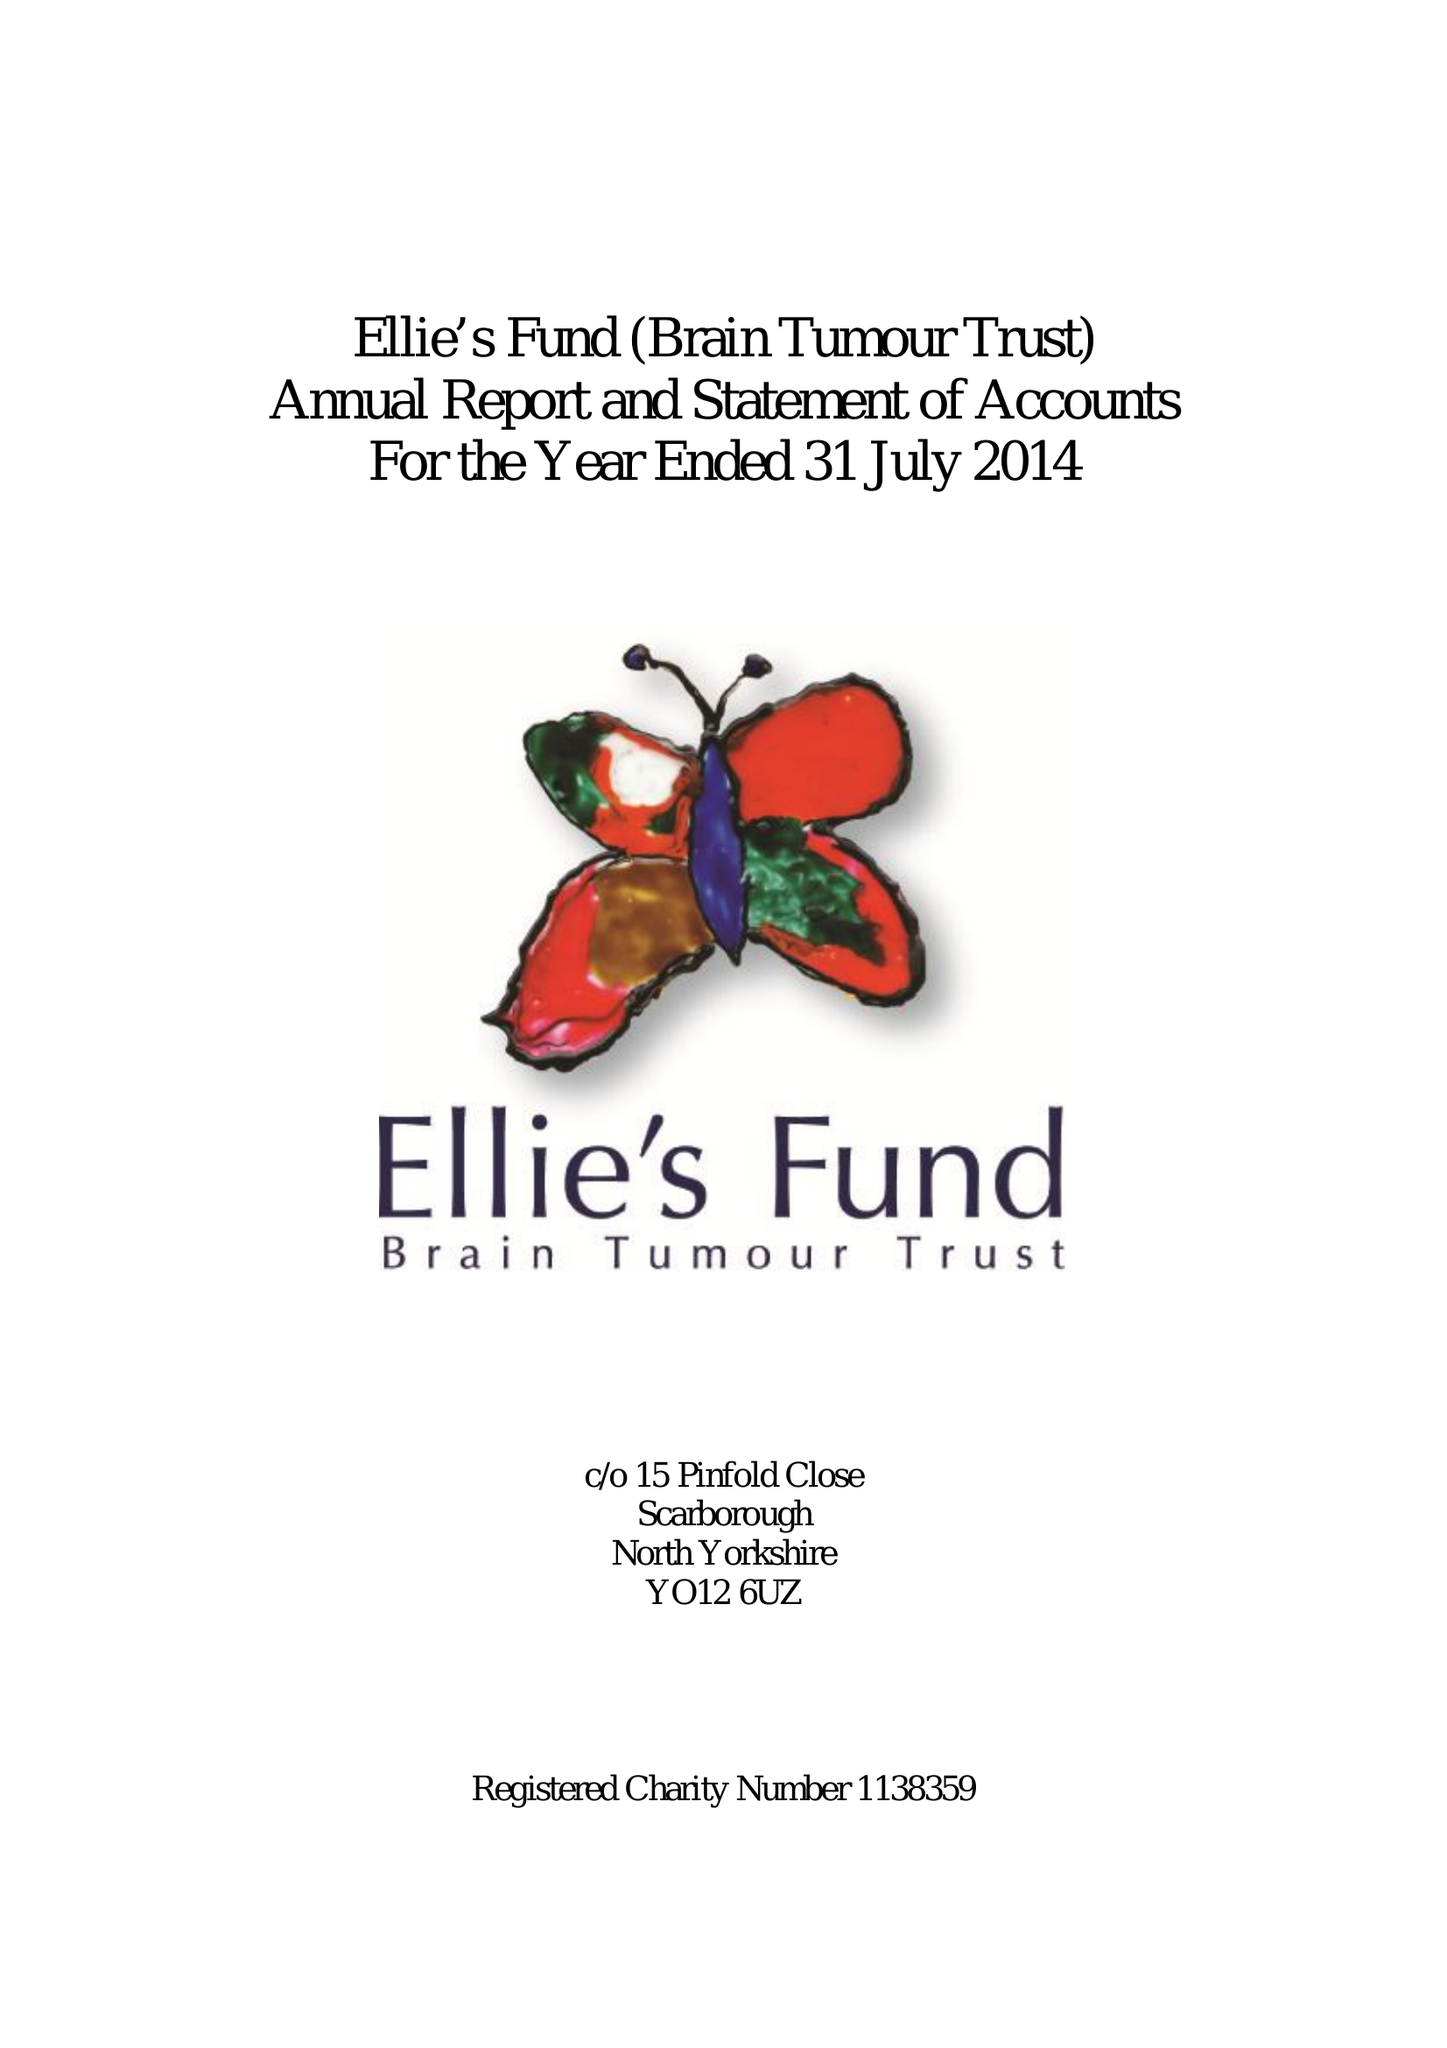What is the value for the income_annually_in_british_pounds?
Answer the question using a single word or phrase. 59376.00 